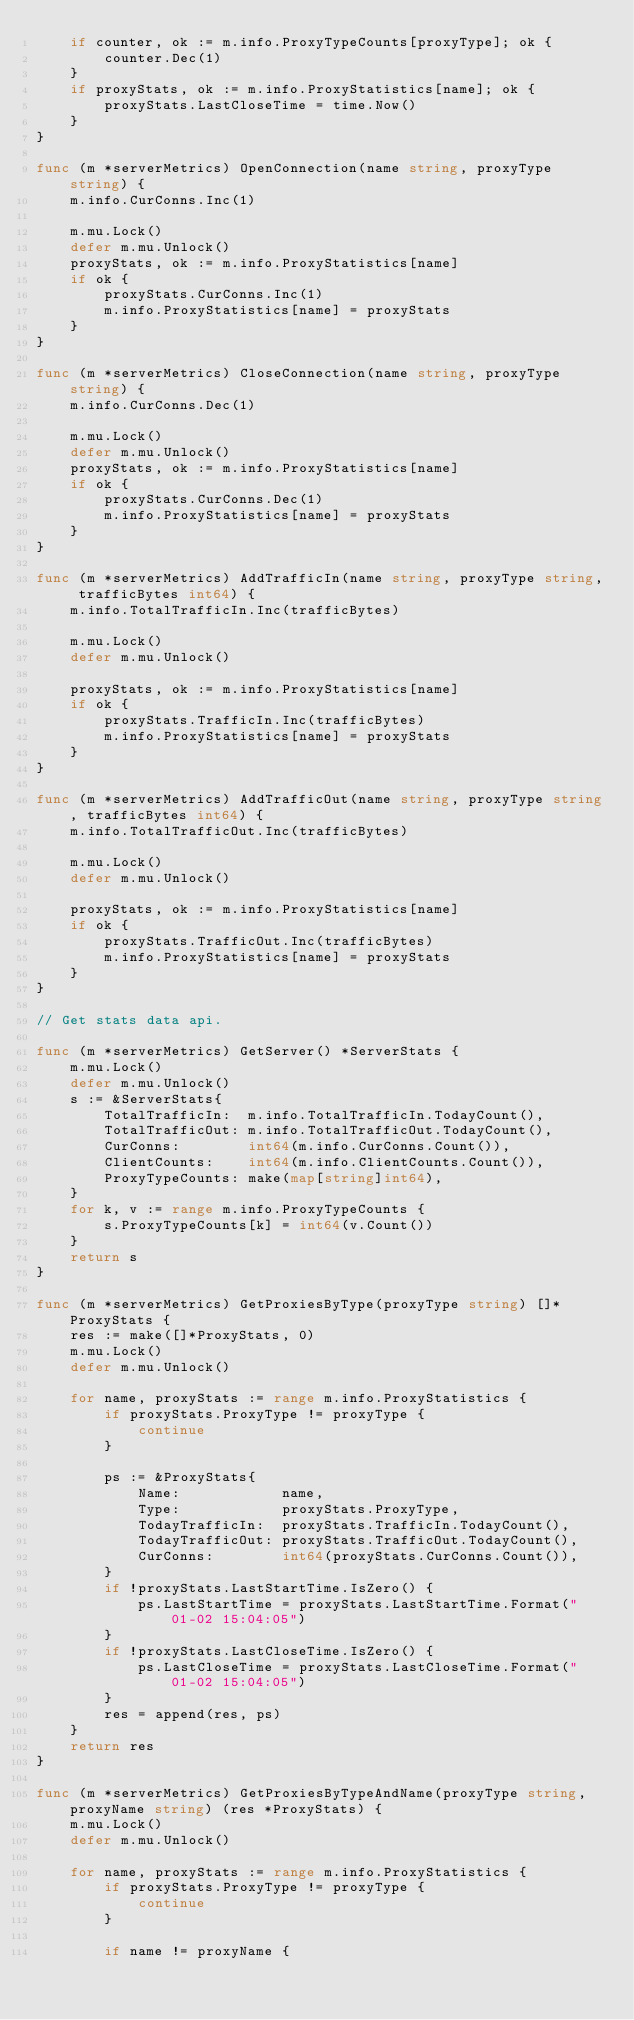<code> <loc_0><loc_0><loc_500><loc_500><_Go_>	if counter, ok := m.info.ProxyTypeCounts[proxyType]; ok {
		counter.Dec(1)
	}
	if proxyStats, ok := m.info.ProxyStatistics[name]; ok {
		proxyStats.LastCloseTime = time.Now()
	}
}

func (m *serverMetrics) OpenConnection(name string, proxyType string) {
	m.info.CurConns.Inc(1)

	m.mu.Lock()
	defer m.mu.Unlock()
	proxyStats, ok := m.info.ProxyStatistics[name]
	if ok {
		proxyStats.CurConns.Inc(1)
		m.info.ProxyStatistics[name] = proxyStats
	}
}

func (m *serverMetrics) CloseConnection(name string, proxyType string) {
	m.info.CurConns.Dec(1)

	m.mu.Lock()
	defer m.mu.Unlock()
	proxyStats, ok := m.info.ProxyStatistics[name]
	if ok {
		proxyStats.CurConns.Dec(1)
		m.info.ProxyStatistics[name] = proxyStats
	}
}

func (m *serverMetrics) AddTrafficIn(name string, proxyType string, trafficBytes int64) {
	m.info.TotalTrafficIn.Inc(trafficBytes)

	m.mu.Lock()
	defer m.mu.Unlock()

	proxyStats, ok := m.info.ProxyStatistics[name]
	if ok {
		proxyStats.TrafficIn.Inc(trafficBytes)
		m.info.ProxyStatistics[name] = proxyStats
	}
}

func (m *serverMetrics) AddTrafficOut(name string, proxyType string, trafficBytes int64) {
	m.info.TotalTrafficOut.Inc(trafficBytes)

	m.mu.Lock()
	defer m.mu.Unlock()

	proxyStats, ok := m.info.ProxyStatistics[name]
	if ok {
		proxyStats.TrafficOut.Inc(trafficBytes)
		m.info.ProxyStatistics[name] = proxyStats
	}
}

// Get stats data api.

func (m *serverMetrics) GetServer() *ServerStats {
	m.mu.Lock()
	defer m.mu.Unlock()
	s := &ServerStats{
		TotalTrafficIn:  m.info.TotalTrafficIn.TodayCount(),
		TotalTrafficOut: m.info.TotalTrafficOut.TodayCount(),
		CurConns:        int64(m.info.CurConns.Count()),
		ClientCounts:    int64(m.info.ClientCounts.Count()),
		ProxyTypeCounts: make(map[string]int64),
	}
	for k, v := range m.info.ProxyTypeCounts {
		s.ProxyTypeCounts[k] = int64(v.Count())
	}
	return s
}

func (m *serverMetrics) GetProxiesByType(proxyType string) []*ProxyStats {
	res := make([]*ProxyStats, 0)
	m.mu.Lock()
	defer m.mu.Unlock()

	for name, proxyStats := range m.info.ProxyStatistics {
		if proxyStats.ProxyType != proxyType {
			continue
		}

		ps := &ProxyStats{
			Name:            name,
			Type:            proxyStats.ProxyType,
			TodayTrafficIn:  proxyStats.TrafficIn.TodayCount(),
			TodayTrafficOut: proxyStats.TrafficOut.TodayCount(),
			CurConns:        int64(proxyStats.CurConns.Count()),
		}
		if !proxyStats.LastStartTime.IsZero() {
			ps.LastStartTime = proxyStats.LastStartTime.Format("01-02 15:04:05")
		}
		if !proxyStats.LastCloseTime.IsZero() {
			ps.LastCloseTime = proxyStats.LastCloseTime.Format("01-02 15:04:05")
		}
		res = append(res, ps)
	}
	return res
}

func (m *serverMetrics) GetProxiesByTypeAndName(proxyType string, proxyName string) (res *ProxyStats) {
	m.mu.Lock()
	defer m.mu.Unlock()

	for name, proxyStats := range m.info.ProxyStatistics {
		if proxyStats.ProxyType != proxyType {
			continue
		}

		if name != proxyName {</code> 